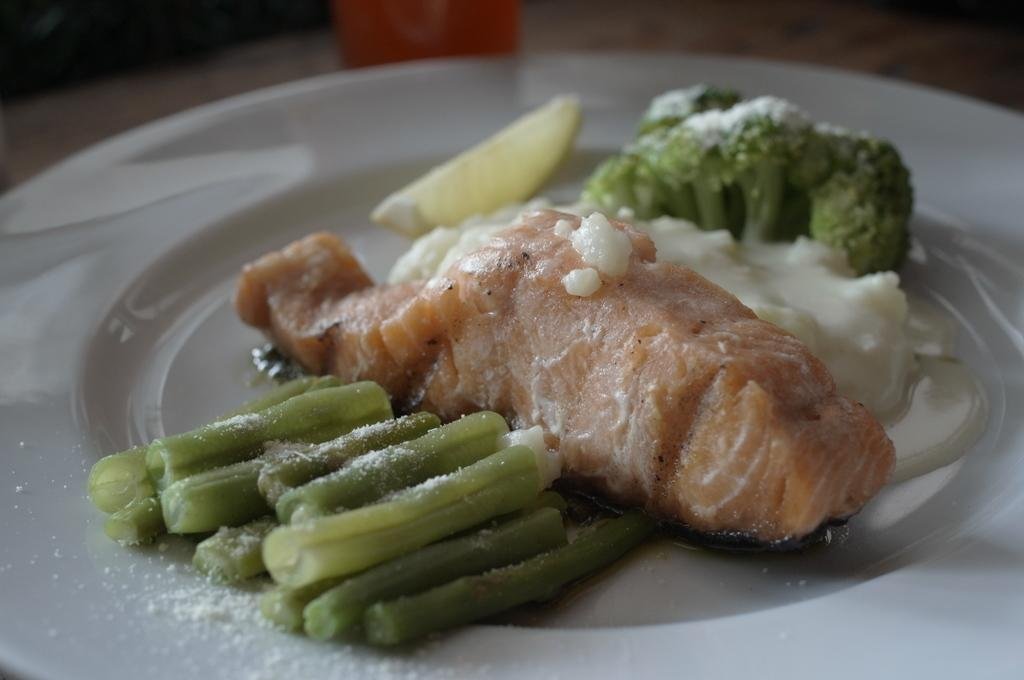What type of food can be seen in the image? The food in the image is in green and brown colors. What color is the plate that the food is on? The plate is in white color. Where is the plate with the food located? The plate is placed on a table. Can you see any tails on the food in the image? There are no tails present on the food in the image. Are there any bells attached to the plate in the image? There are no bells present on the plate in the image. 